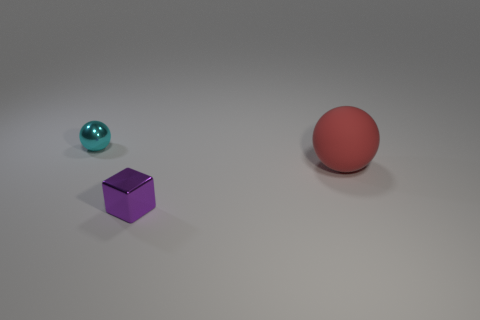Add 2 large cyan shiny cylinders. How many objects exist? 5 Subtract all balls. How many objects are left? 1 Add 3 big yellow things. How many big yellow things exist? 3 Subtract 0 yellow balls. How many objects are left? 3 Subtract all green blocks. Subtract all brown cylinders. How many blocks are left? 1 Subtract all big green rubber objects. Subtract all big red matte things. How many objects are left? 2 Add 1 cyan metal objects. How many cyan metal objects are left? 2 